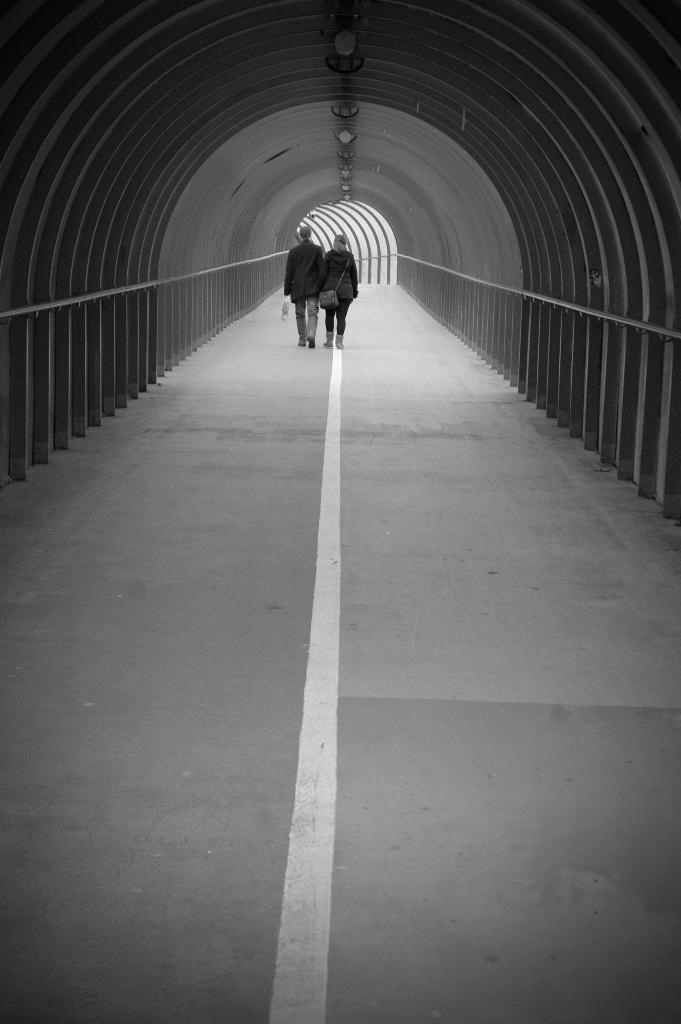Who is present in the image? There is a couple in the image. What are the couple doing in the image? The couple is walking on the road in the image. Where is the couple located in the image? The couple is inside a tunnel in the image. What is the color scheme of the image? The image is black and white. What is the weight of the wool in the image? There is no wool present in the image, so it is not possible to determine its weight. 